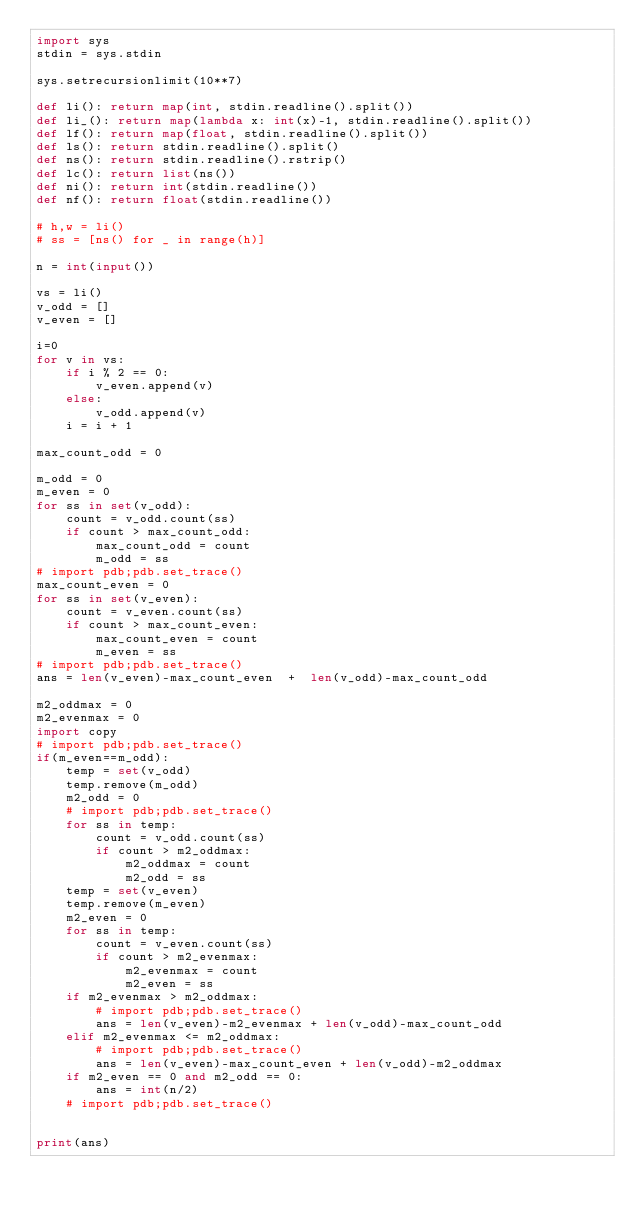<code> <loc_0><loc_0><loc_500><loc_500><_Python_>import sys
stdin = sys.stdin
 
sys.setrecursionlimit(10**7) 
 
def li(): return map(int, stdin.readline().split())
def li_(): return map(lambda x: int(x)-1, stdin.readline().split())
def lf(): return map(float, stdin.readline().split())
def ls(): return stdin.readline().split()
def ns(): return stdin.readline().rstrip()
def lc(): return list(ns())
def ni(): return int(stdin.readline())
def nf(): return float(stdin.readline())
 
# h,w = li()
# ss = [ns() for _ in range(h)]

n = int(input())

vs = li()
v_odd = []
v_even = []

i=0
for v in vs:
    if i % 2 == 0:
        v_even.append(v)
    else:
        v_odd.append(v)
    i = i + 1

max_count_odd = 0

m_odd = 0
m_even = 0
for ss in set(v_odd):
    count = v_odd.count(ss)
    if count > max_count_odd:
        max_count_odd = count
        m_odd = ss
# import pdb;pdb.set_trace() 
max_count_even = 0
for ss in set(v_even):
    count = v_even.count(ss)
    if count > max_count_even:
        max_count_even = count
        m_even = ss
# import pdb;pdb.set_trace() 
ans = len(v_even)-max_count_even  +  len(v_odd)-max_count_odd

m2_oddmax = 0
m2_evenmax = 0
import copy
# import pdb;pdb.set_trace()
if(m_even==m_odd):
    temp = set(v_odd)
    temp.remove(m_odd)
    m2_odd = 0
    # import pdb;pdb.set_trace()
    for ss in temp:
        count = v_odd.count(ss)
        if count > m2_oddmax:
            m2_oddmax = count
            m2_odd = ss
    temp = set(v_even)
    temp.remove(m_even)
    m2_even = 0
    for ss in temp:
        count = v_even.count(ss)
        if count > m2_evenmax:
            m2_evenmax = count
            m2_even = ss
    if m2_evenmax > m2_oddmax:
        # import pdb;pdb.set_trace()
        ans = len(v_even)-m2_evenmax + len(v_odd)-max_count_odd
    elif m2_evenmax <= m2_oddmax:
        # import pdb;pdb.set_trace()
        ans = len(v_even)-max_count_even + len(v_odd)-m2_oddmax
    if m2_even == 0 and m2_odd == 0:
        ans = int(n/2)
    # import pdb;pdb.set_trace()


print(ans)
</code> 